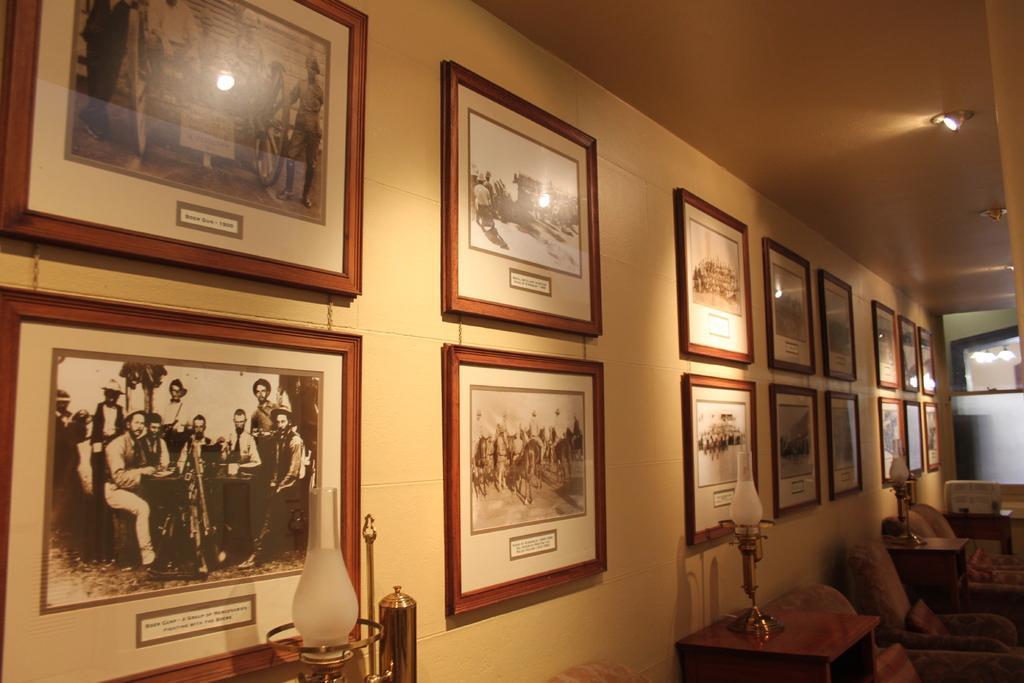Please provide a concise description of this image. At the bottom of the picture, we see a lamp. In the right bottom, we see the chairs, cushions and the tables on which the lamps are placed. In the background, we see a white wall on which many photo frames are placed. On the right side, we see a white table and the lights. In the right top, we see the ceiling of the room. 